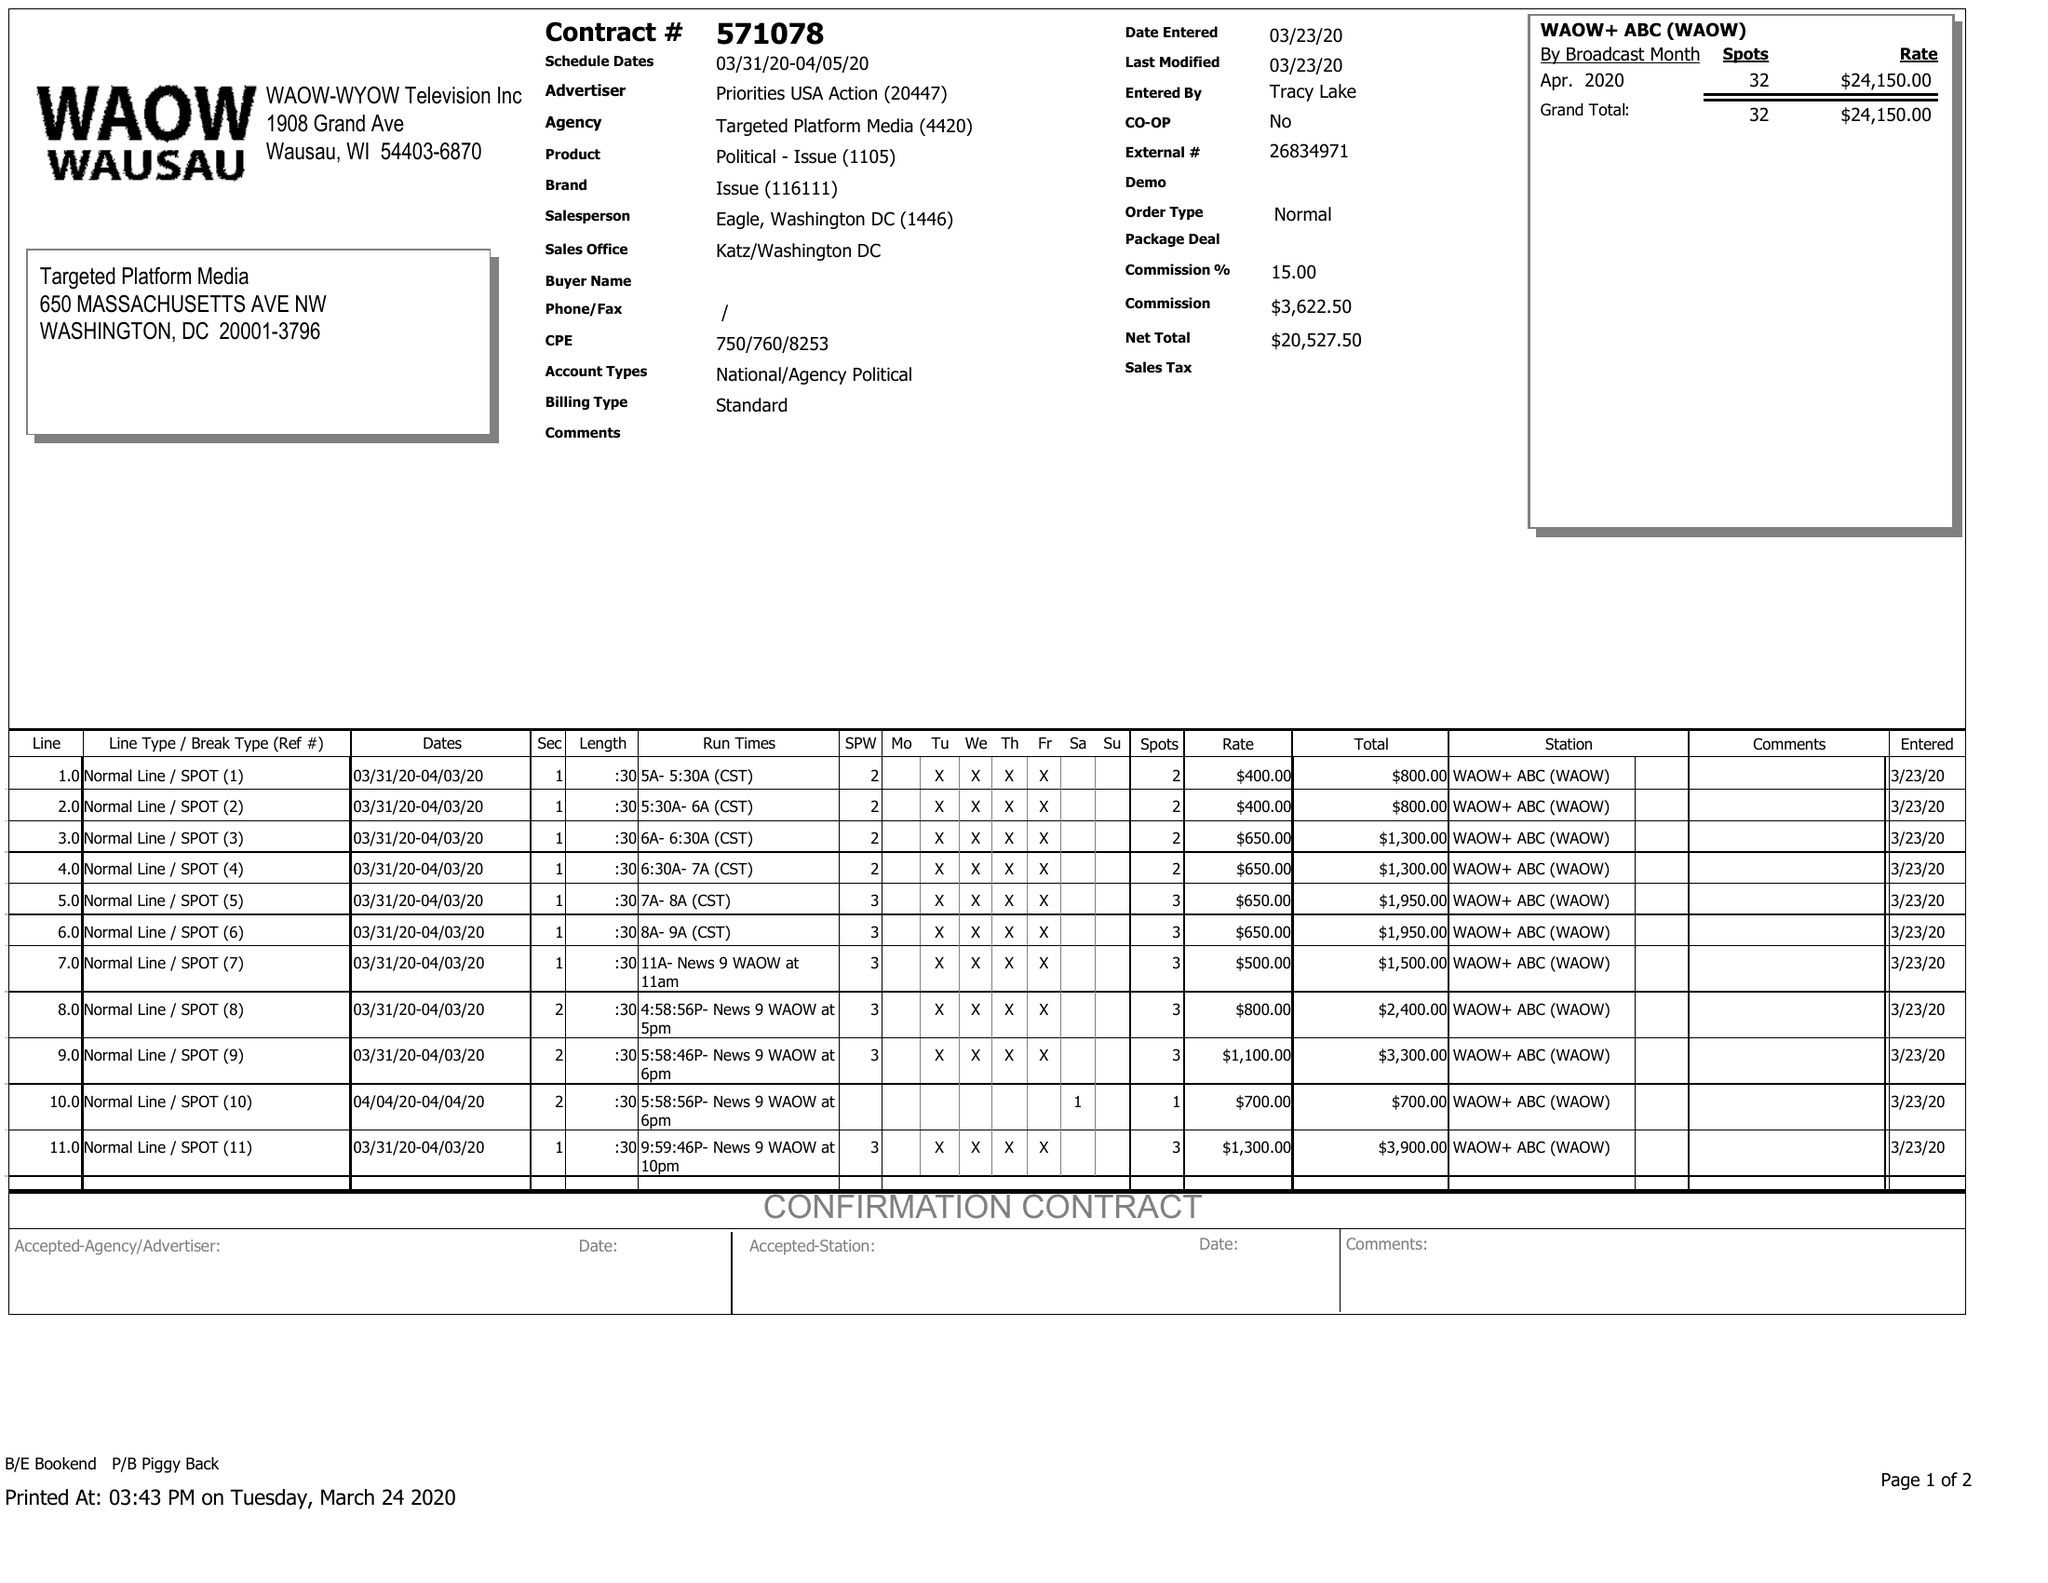What is the value for the flight_to?
Answer the question using a single word or phrase. 04/05/20 